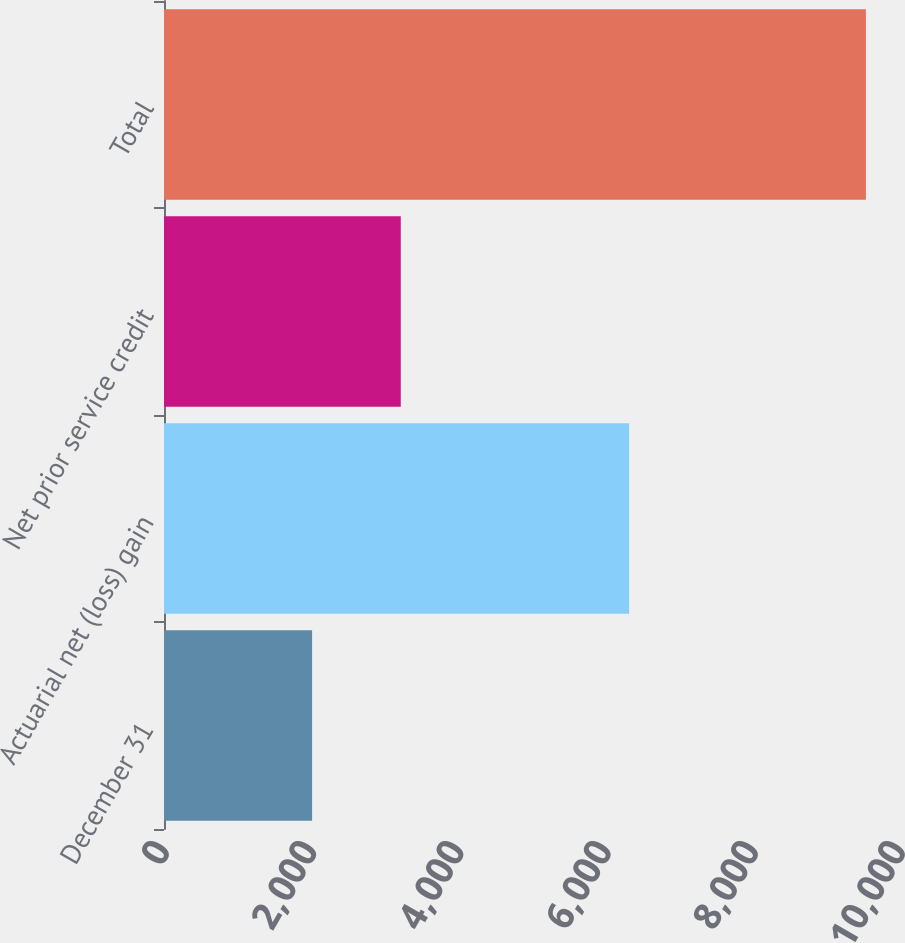<chart> <loc_0><loc_0><loc_500><loc_500><bar_chart><fcel>December 31<fcel>Actuarial net (loss) gain<fcel>Net prior service credit<fcel>Total<nl><fcel>2012<fcel>6320<fcel>3217<fcel>9537<nl></chart> 